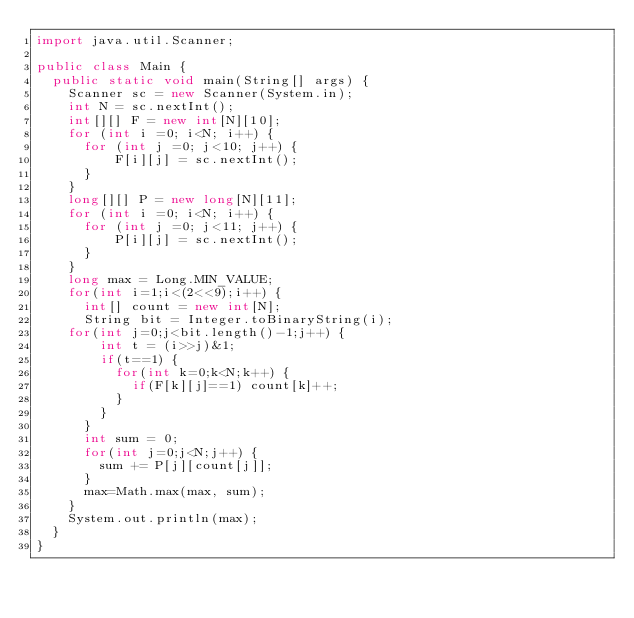Convert code to text. <code><loc_0><loc_0><loc_500><loc_500><_Java_>import java.util.Scanner;

public class Main { 
  public static void main(String[] args) {
    Scanner sc = new Scanner(System.in);
    int N = sc.nextInt();
    int[][] F = new int[N][10];
    for (int i =0; i<N; i++) {
      for (int j =0; j<10; j++) {
          F[i][j] = sc.nextInt();
      }
    }
    long[][] P = new long[N][11];
    for (int i =0; i<N; i++) {
      for (int j =0; j<11; j++) {
          P[i][j] = sc.nextInt();
      }
    }
    long max = Long.MIN_VALUE; 
    for(int i=1;i<(2<<9);i++) {
      int[] count = new int[N];
      String bit = Integer.toBinaryString(i);
	  for(int j=0;j<bit.length()-1;j++) {
        int t = (i>>j)&1;
        if(t==1) {
          for(int k=0;k<N;k++) {
            if(F[k][j]==1) count[k]++;
          }
        }
      }   
      int sum = 0;
      for(int j=0;j<N;j++) {
        sum += P[j][count[j]];
      }
      max=Math.max(max, sum);
    }      
    System.out.println(max);  
  }
}</code> 